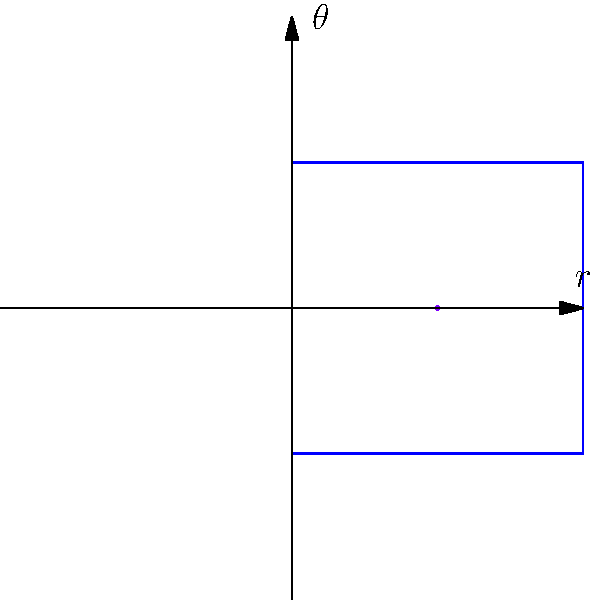As a fine-art photographer, you want to incorporate the golden spiral into your compositions. If the polar equation of the golden spiral is given by $r = ae^{b\theta}$, where $a$ is a scaling factor and $b = \frac{\ln(\phi)}{2\pi}$ ($\phi$ being the golden ratio), what is the value of $b$ rounded to four decimal places? To find the value of $b$, we need to follow these steps:

1) First, recall that the golden ratio $\phi$ is given by:
   $\phi = \frac{1 + \sqrt{5}}{2}$

2) Calculate the value of $\phi$:
   $\phi = \frac{1 + \sqrt{5}}{2} \approx 1.6180339887$

3) Now, we can use the formula for $b$:
   $b = \frac{\ln(\phi)}{2\pi}$

4) Calculate $\ln(\phi)$:
   $\ln(\phi) \approx 0.4812118250$

5) Divide by $2\pi$:
   $b = \frac{0.4812118250}{2\pi} \approx 0.0766$

6) Rounding to four decimal places:
   $b \approx 0.0766$

This value of $b$ determines the rate at which the spiral expands, creating the characteristic golden spiral shape that can be used to guide compositional elements in your photographs.
Answer: 0.0766 